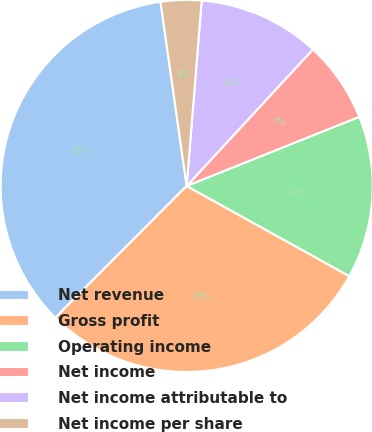<chart> <loc_0><loc_0><loc_500><loc_500><pie_chart><fcel>Net revenue<fcel>Gross profit<fcel>Operating income<fcel>Net income<fcel>Net income attributable to<fcel>Net income per share<nl><fcel>35.28%<fcel>29.42%<fcel>14.12%<fcel>7.06%<fcel>10.59%<fcel>3.53%<nl></chart> 